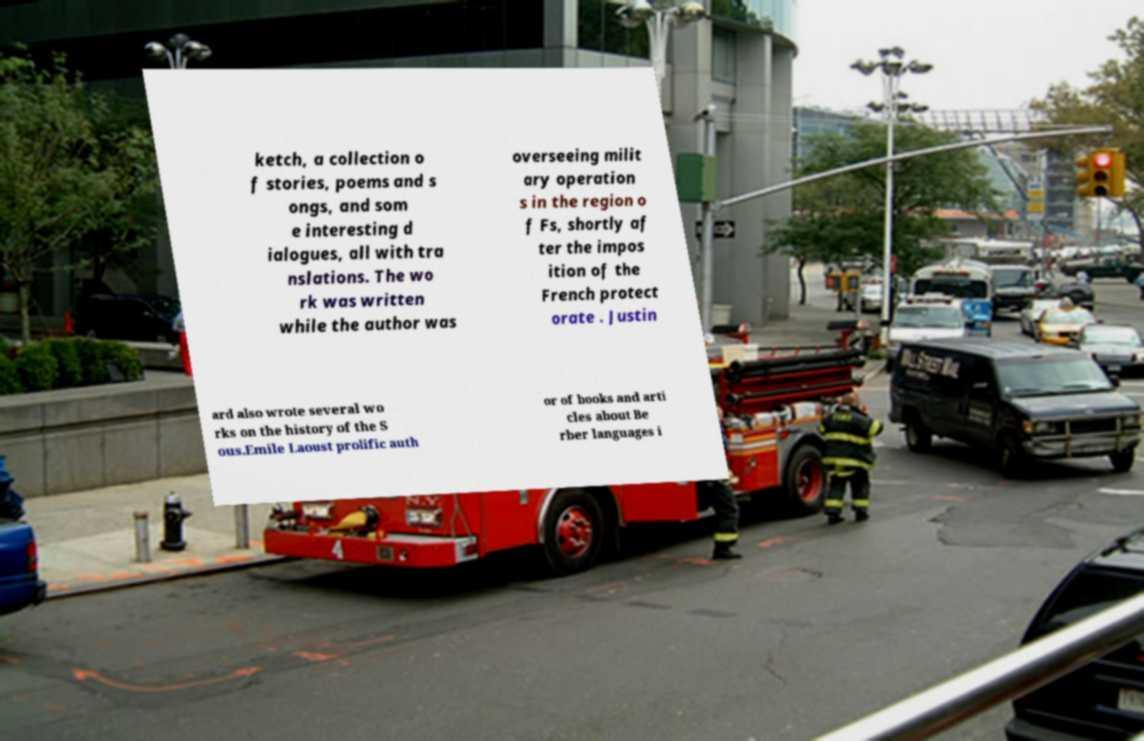Could you assist in decoding the text presented in this image and type it out clearly? ketch, a collection o f stories, poems and s ongs, and som e interesting d ialogues, all with tra nslations. The wo rk was written while the author was overseeing milit ary operation s in the region o f Fs, shortly af ter the impos ition of the French protect orate . Justin ard also wrote several wo rks on the history of the S ous.Emile Laoust prolific auth or of books and arti cles about Be rber languages i 